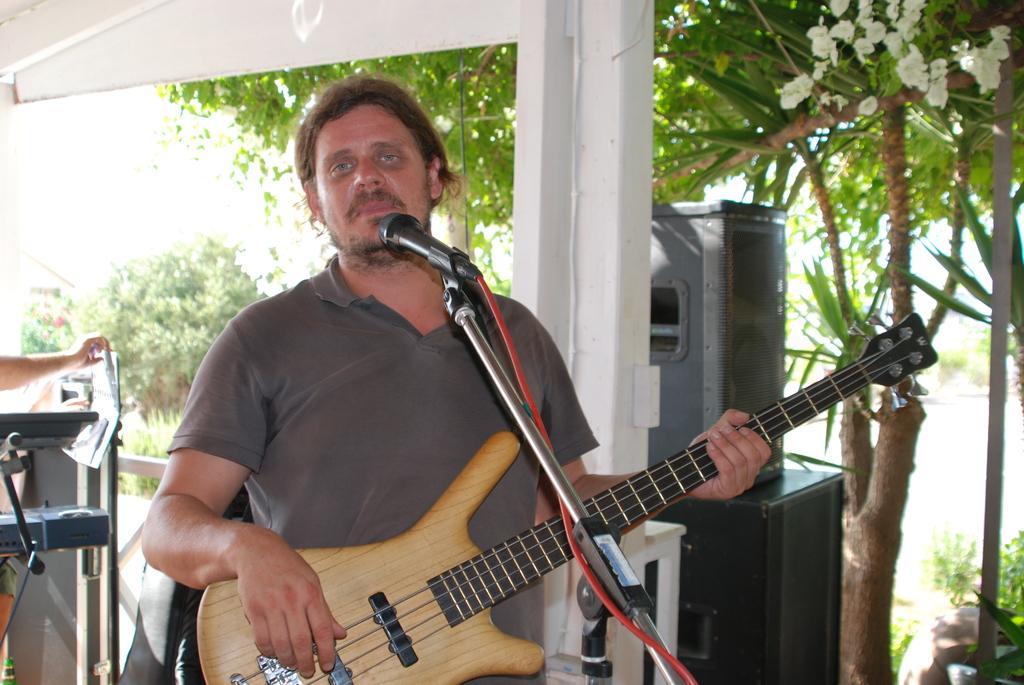In one or two sentences, can you explain what this image depicts? In the picture we can find a man standing holding the guitar near the microphone. In the background we can find some sound boxes, trees, plants and some instruments. 